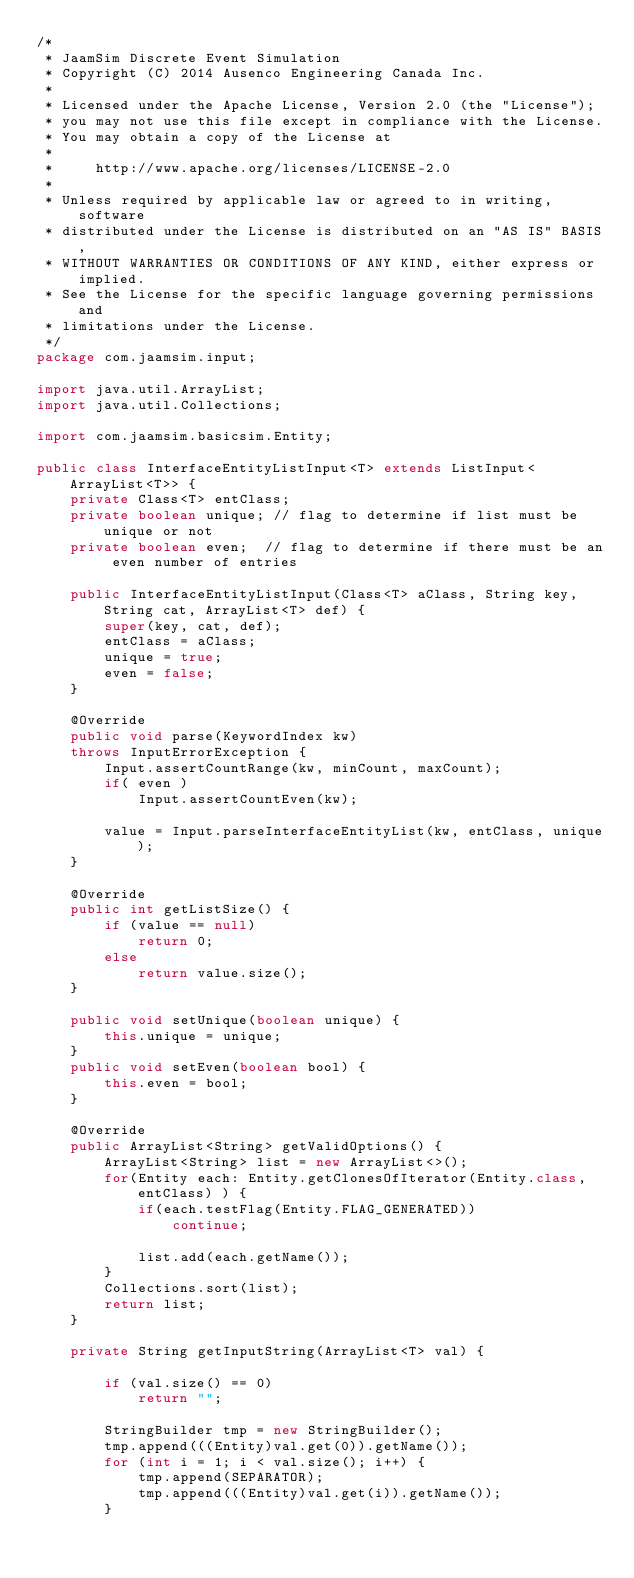<code> <loc_0><loc_0><loc_500><loc_500><_Java_>/*
 * JaamSim Discrete Event Simulation
 * Copyright (C) 2014 Ausenco Engineering Canada Inc.
 *
 * Licensed under the Apache License, Version 2.0 (the "License");
 * you may not use this file except in compliance with the License.
 * You may obtain a copy of the License at
 *
 *     http://www.apache.org/licenses/LICENSE-2.0
 *
 * Unless required by applicable law or agreed to in writing, software
 * distributed under the License is distributed on an "AS IS" BASIS,
 * WITHOUT WARRANTIES OR CONDITIONS OF ANY KIND, either express or implied.
 * See the License for the specific language governing permissions and
 * limitations under the License.
 */
package com.jaamsim.input;

import java.util.ArrayList;
import java.util.Collections;

import com.jaamsim.basicsim.Entity;

public class InterfaceEntityListInput<T> extends ListInput<ArrayList<T>> {
	private Class<T> entClass;
	private boolean unique; // flag to determine if list must be unique or not
	private boolean even;  // flag to determine if there must be an even number of entries

	public InterfaceEntityListInput(Class<T> aClass, String key, String cat, ArrayList<T> def) {
		super(key, cat, def);
		entClass = aClass;
		unique = true;
		even = false;
	}

	@Override
	public void parse(KeywordIndex kw)
	throws InputErrorException {
		Input.assertCountRange(kw, minCount, maxCount);
		if( even )
			Input.assertCountEven(kw);

		value = Input.parseInterfaceEntityList(kw, entClass, unique);
	}

	@Override
	public int getListSize() {
		if (value == null)
			return 0;
		else
			return value.size();
	}

	public void setUnique(boolean unique) {
		this.unique = unique;
	}
	public void setEven(boolean bool) {
		this.even = bool;
	}

	@Override
	public ArrayList<String> getValidOptions() {
		ArrayList<String> list = new ArrayList<>();
		for(Entity each: Entity.getClonesOfIterator(Entity.class, entClass) ) {
			if(each.testFlag(Entity.FLAG_GENERATED))
				continue;

			list.add(each.getName());
		}
		Collections.sort(list);
		return list;
	}

	private String getInputString(ArrayList<T> val) {

		if (val.size() == 0)
			return "";

		StringBuilder tmp = new StringBuilder();
		tmp.append(((Entity)val.get(0)).getName());
		for (int i = 1; i < val.size(); i++) {
			tmp.append(SEPARATOR);
			tmp.append(((Entity)val.get(i)).getName());
		}</code> 